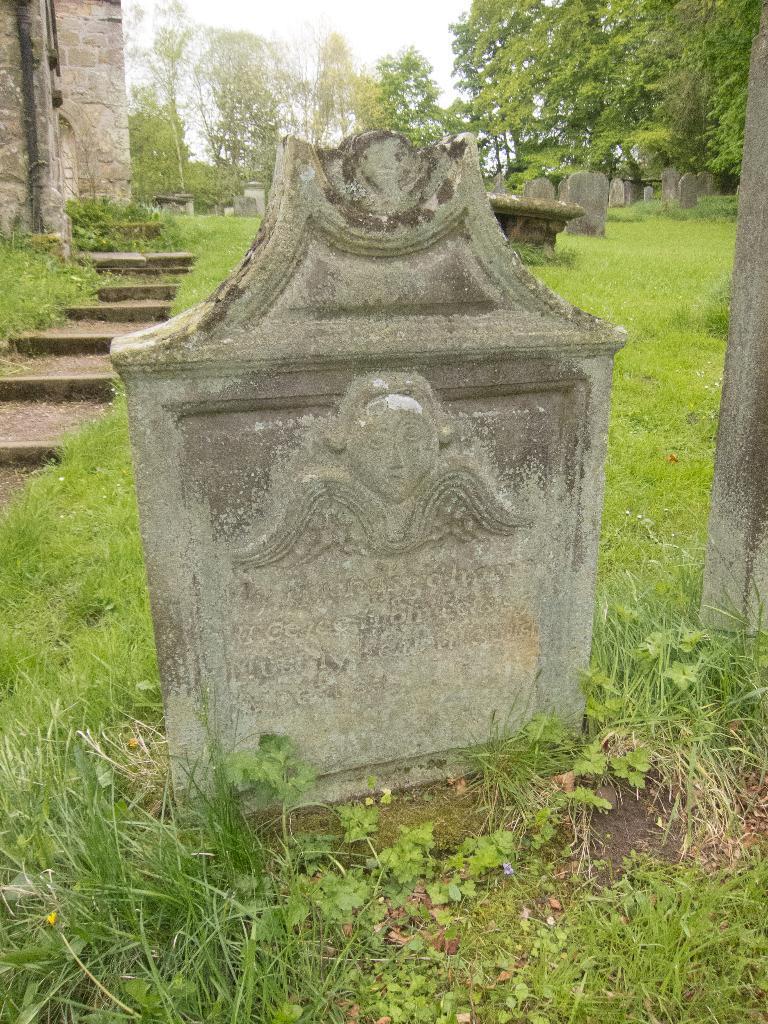How would you summarize this image in a sentence or two? In this image I can see cemeteries, grass, building, trees and the sky. This image is taken may be during a day. 